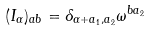<formula> <loc_0><loc_0><loc_500><loc_500>( I _ { \alpha } ) _ { a b } = \delta _ { \alpha + a _ { 1 } , a _ { 2 } } \omega ^ { b a _ { 2 } }</formula> 